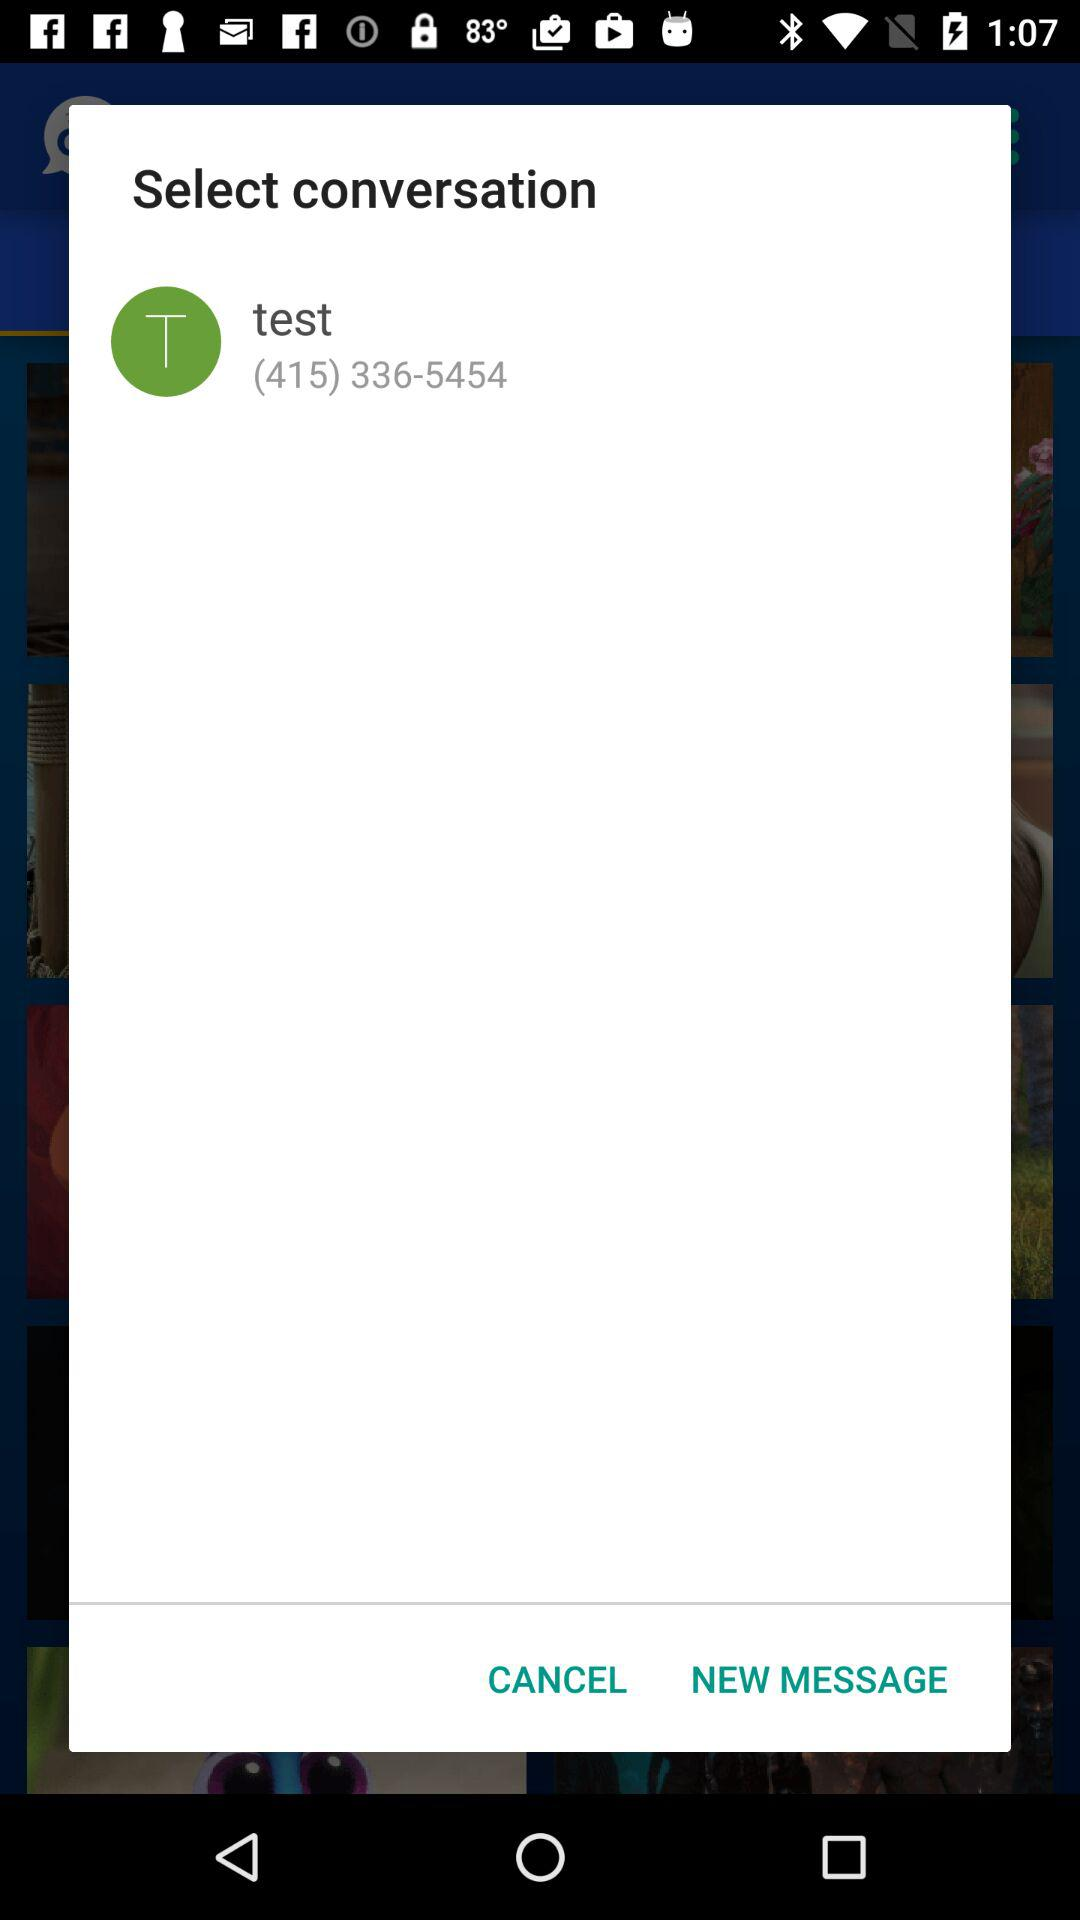What is the phone number given? The given phone number is (415) 336-5454. 